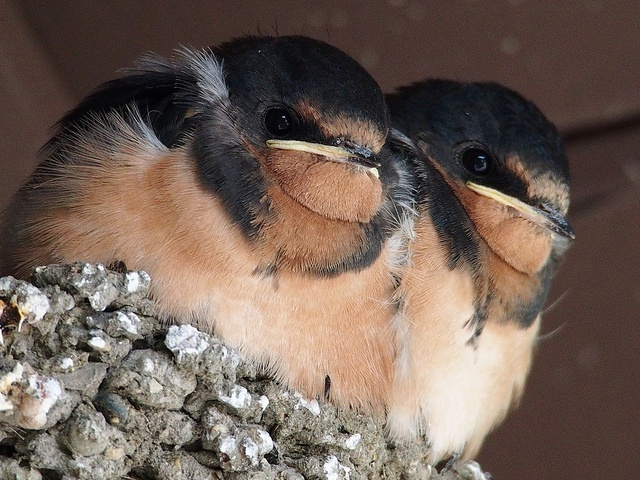Describe the objects in this image and their specific colors. I can see bird in maroon, black, tan, and gray tones and bird in maroon, black, lightgray, and tan tones in this image. 